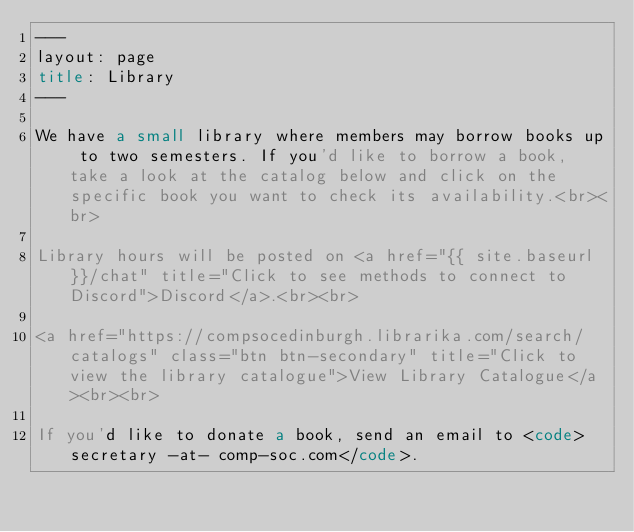Convert code to text. <code><loc_0><loc_0><loc_500><loc_500><_HTML_>---
layout: page
title: Library
---

We have a small library where members may borrow books up to two semesters. If you'd like to borrow a book, take a look at the catalog below and click on the specific book you want to check its availability.<br><br>

Library hours will be posted on <a href="{{ site.baseurl }}/chat" title="Click to see methods to connect to Discord">Discord</a>.<br><br>

<a href="https://compsocedinburgh.librarika.com/search/catalogs" class="btn btn-secondary" title="Click to view the library catalogue">View Library Catalogue</a><br><br>

If you'd like to donate a book, send an email to <code>secretary -at- comp-soc.com</code>.
</code> 